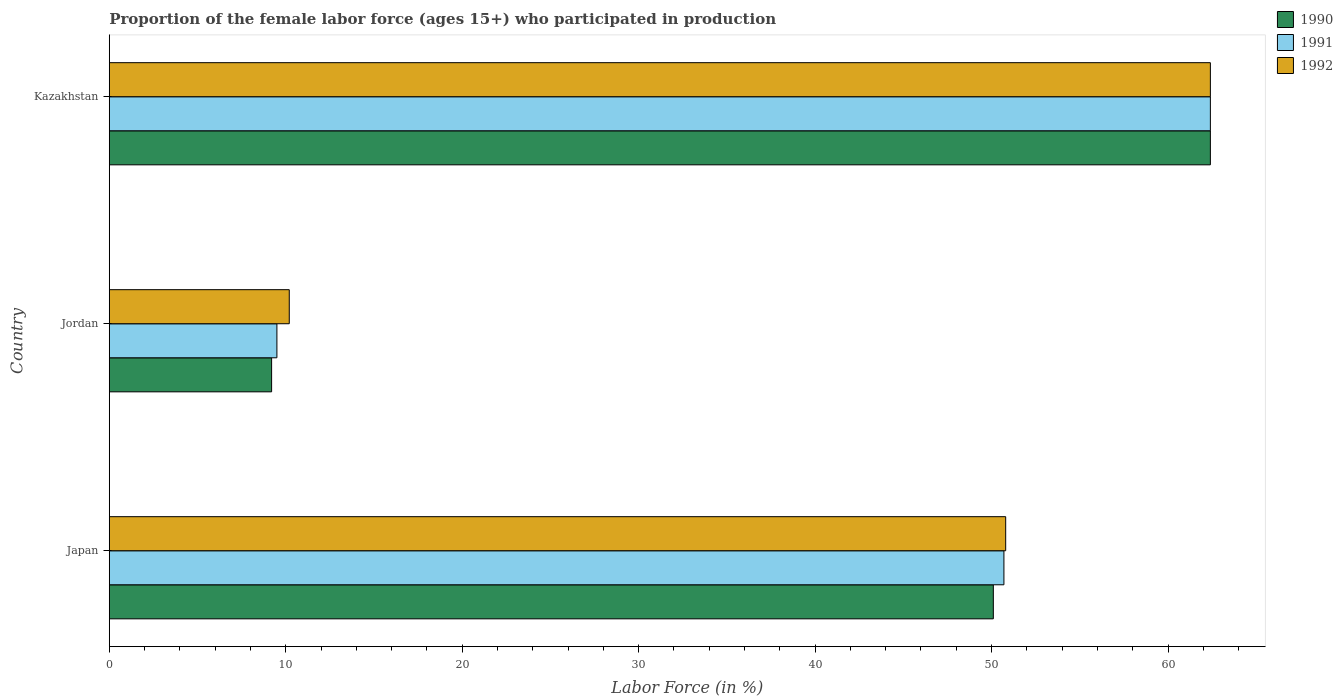How many groups of bars are there?
Give a very brief answer. 3. How many bars are there on the 3rd tick from the bottom?
Offer a terse response. 3. What is the label of the 2nd group of bars from the top?
Provide a short and direct response. Jordan. In how many cases, is the number of bars for a given country not equal to the number of legend labels?
Your answer should be compact. 0. What is the proportion of the female labor force who participated in production in 1992 in Jordan?
Offer a terse response. 10.2. Across all countries, what is the maximum proportion of the female labor force who participated in production in 1991?
Your answer should be compact. 62.4. Across all countries, what is the minimum proportion of the female labor force who participated in production in 1992?
Make the answer very short. 10.2. In which country was the proportion of the female labor force who participated in production in 1990 maximum?
Your answer should be very brief. Kazakhstan. In which country was the proportion of the female labor force who participated in production in 1990 minimum?
Keep it short and to the point. Jordan. What is the total proportion of the female labor force who participated in production in 1991 in the graph?
Keep it short and to the point. 122.6. What is the difference between the proportion of the female labor force who participated in production in 1992 in Jordan and that in Kazakhstan?
Keep it short and to the point. -52.2. What is the difference between the proportion of the female labor force who participated in production in 1991 in Japan and the proportion of the female labor force who participated in production in 1990 in Kazakhstan?
Provide a succinct answer. -11.7. What is the average proportion of the female labor force who participated in production in 1992 per country?
Your answer should be compact. 41.13. What is the difference between the proportion of the female labor force who participated in production in 1990 and proportion of the female labor force who participated in production in 1991 in Jordan?
Provide a succinct answer. -0.3. In how many countries, is the proportion of the female labor force who participated in production in 1992 greater than 8 %?
Provide a short and direct response. 3. What is the ratio of the proportion of the female labor force who participated in production in 1992 in Japan to that in Kazakhstan?
Provide a short and direct response. 0.81. Is the difference between the proportion of the female labor force who participated in production in 1990 in Jordan and Kazakhstan greater than the difference between the proportion of the female labor force who participated in production in 1991 in Jordan and Kazakhstan?
Keep it short and to the point. No. What is the difference between the highest and the second highest proportion of the female labor force who participated in production in 1990?
Make the answer very short. 12.3. What is the difference between the highest and the lowest proportion of the female labor force who participated in production in 1990?
Provide a short and direct response. 53.2. In how many countries, is the proportion of the female labor force who participated in production in 1990 greater than the average proportion of the female labor force who participated in production in 1990 taken over all countries?
Your answer should be compact. 2. What does the 2nd bar from the top in Jordan represents?
Offer a very short reply. 1991. Is it the case that in every country, the sum of the proportion of the female labor force who participated in production in 1992 and proportion of the female labor force who participated in production in 1990 is greater than the proportion of the female labor force who participated in production in 1991?
Your response must be concise. Yes. Are all the bars in the graph horizontal?
Offer a terse response. Yes. Are the values on the major ticks of X-axis written in scientific E-notation?
Provide a short and direct response. No. What is the title of the graph?
Your answer should be very brief. Proportion of the female labor force (ages 15+) who participated in production. What is the label or title of the Y-axis?
Your answer should be very brief. Country. What is the Labor Force (in %) in 1990 in Japan?
Your answer should be very brief. 50.1. What is the Labor Force (in %) in 1991 in Japan?
Make the answer very short. 50.7. What is the Labor Force (in %) of 1992 in Japan?
Keep it short and to the point. 50.8. What is the Labor Force (in %) of 1990 in Jordan?
Offer a terse response. 9.2. What is the Labor Force (in %) of 1991 in Jordan?
Make the answer very short. 9.5. What is the Labor Force (in %) of 1992 in Jordan?
Your answer should be compact. 10.2. What is the Labor Force (in %) in 1990 in Kazakhstan?
Make the answer very short. 62.4. What is the Labor Force (in %) in 1991 in Kazakhstan?
Your answer should be compact. 62.4. What is the Labor Force (in %) of 1992 in Kazakhstan?
Offer a terse response. 62.4. Across all countries, what is the maximum Labor Force (in %) in 1990?
Ensure brevity in your answer.  62.4. Across all countries, what is the maximum Labor Force (in %) in 1991?
Your answer should be very brief. 62.4. Across all countries, what is the maximum Labor Force (in %) in 1992?
Make the answer very short. 62.4. Across all countries, what is the minimum Labor Force (in %) of 1990?
Give a very brief answer. 9.2. Across all countries, what is the minimum Labor Force (in %) of 1991?
Offer a very short reply. 9.5. Across all countries, what is the minimum Labor Force (in %) in 1992?
Give a very brief answer. 10.2. What is the total Labor Force (in %) in 1990 in the graph?
Your answer should be compact. 121.7. What is the total Labor Force (in %) of 1991 in the graph?
Make the answer very short. 122.6. What is the total Labor Force (in %) of 1992 in the graph?
Ensure brevity in your answer.  123.4. What is the difference between the Labor Force (in %) of 1990 in Japan and that in Jordan?
Your response must be concise. 40.9. What is the difference between the Labor Force (in %) in 1991 in Japan and that in Jordan?
Keep it short and to the point. 41.2. What is the difference between the Labor Force (in %) in 1992 in Japan and that in Jordan?
Keep it short and to the point. 40.6. What is the difference between the Labor Force (in %) of 1992 in Japan and that in Kazakhstan?
Make the answer very short. -11.6. What is the difference between the Labor Force (in %) in 1990 in Jordan and that in Kazakhstan?
Ensure brevity in your answer.  -53.2. What is the difference between the Labor Force (in %) in 1991 in Jordan and that in Kazakhstan?
Keep it short and to the point. -52.9. What is the difference between the Labor Force (in %) of 1992 in Jordan and that in Kazakhstan?
Provide a succinct answer. -52.2. What is the difference between the Labor Force (in %) in 1990 in Japan and the Labor Force (in %) in 1991 in Jordan?
Your response must be concise. 40.6. What is the difference between the Labor Force (in %) of 1990 in Japan and the Labor Force (in %) of 1992 in Jordan?
Ensure brevity in your answer.  39.9. What is the difference between the Labor Force (in %) of 1991 in Japan and the Labor Force (in %) of 1992 in Jordan?
Make the answer very short. 40.5. What is the difference between the Labor Force (in %) of 1990 in Japan and the Labor Force (in %) of 1992 in Kazakhstan?
Ensure brevity in your answer.  -12.3. What is the difference between the Labor Force (in %) in 1991 in Japan and the Labor Force (in %) in 1992 in Kazakhstan?
Offer a very short reply. -11.7. What is the difference between the Labor Force (in %) of 1990 in Jordan and the Labor Force (in %) of 1991 in Kazakhstan?
Ensure brevity in your answer.  -53.2. What is the difference between the Labor Force (in %) in 1990 in Jordan and the Labor Force (in %) in 1992 in Kazakhstan?
Provide a short and direct response. -53.2. What is the difference between the Labor Force (in %) in 1991 in Jordan and the Labor Force (in %) in 1992 in Kazakhstan?
Provide a succinct answer. -52.9. What is the average Labor Force (in %) of 1990 per country?
Keep it short and to the point. 40.57. What is the average Labor Force (in %) of 1991 per country?
Offer a very short reply. 40.87. What is the average Labor Force (in %) of 1992 per country?
Provide a short and direct response. 41.13. What is the difference between the Labor Force (in %) in 1990 and Labor Force (in %) in 1991 in Jordan?
Provide a succinct answer. -0.3. What is the difference between the Labor Force (in %) in 1991 and Labor Force (in %) in 1992 in Jordan?
Your answer should be compact. -0.7. What is the difference between the Labor Force (in %) of 1991 and Labor Force (in %) of 1992 in Kazakhstan?
Provide a succinct answer. 0. What is the ratio of the Labor Force (in %) of 1990 in Japan to that in Jordan?
Offer a terse response. 5.45. What is the ratio of the Labor Force (in %) in 1991 in Japan to that in Jordan?
Provide a short and direct response. 5.34. What is the ratio of the Labor Force (in %) of 1992 in Japan to that in Jordan?
Provide a succinct answer. 4.98. What is the ratio of the Labor Force (in %) in 1990 in Japan to that in Kazakhstan?
Offer a very short reply. 0.8. What is the ratio of the Labor Force (in %) of 1991 in Japan to that in Kazakhstan?
Give a very brief answer. 0.81. What is the ratio of the Labor Force (in %) in 1992 in Japan to that in Kazakhstan?
Your response must be concise. 0.81. What is the ratio of the Labor Force (in %) in 1990 in Jordan to that in Kazakhstan?
Offer a very short reply. 0.15. What is the ratio of the Labor Force (in %) in 1991 in Jordan to that in Kazakhstan?
Offer a very short reply. 0.15. What is the ratio of the Labor Force (in %) in 1992 in Jordan to that in Kazakhstan?
Your answer should be compact. 0.16. What is the difference between the highest and the second highest Labor Force (in %) in 1990?
Provide a short and direct response. 12.3. What is the difference between the highest and the second highest Labor Force (in %) of 1991?
Offer a terse response. 11.7. What is the difference between the highest and the lowest Labor Force (in %) of 1990?
Make the answer very short. 53.2. What is the difference between the highest and the lowest Labor Force (in %) of 1991?
Offer a terse response. 52.9. What is the difference between the highest and the lowest Labor Force (in %) in 1992?
Your answer should be very brief. 52.2. 